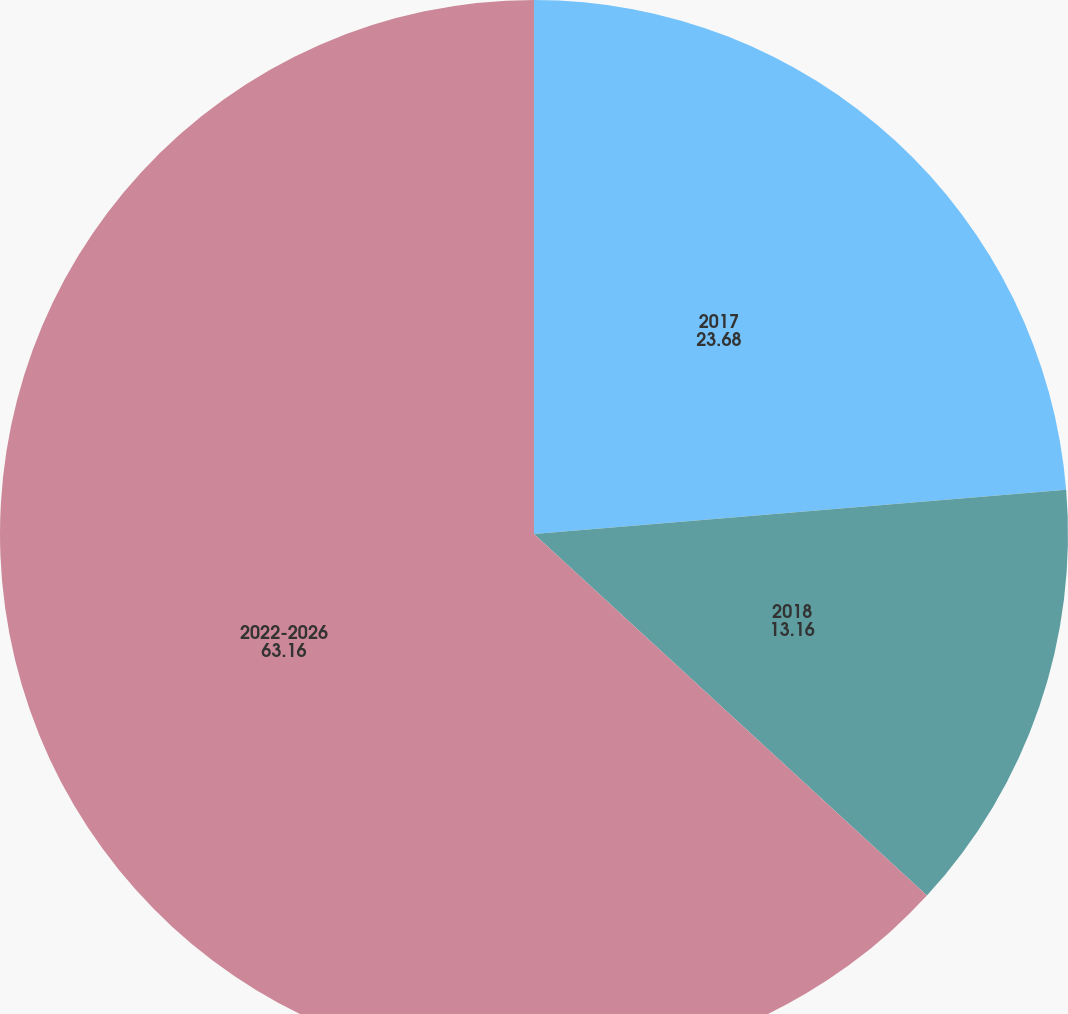Convert chart to OTSL. <chart><loc_0><loc_0><loc_500><loc_500><pie_chart><fcel>2017<fcel>2018<fcel>2022-2026<nl><fcel>23.68%<fcel>13.16%<fcel>63.16%<nl></chart> 